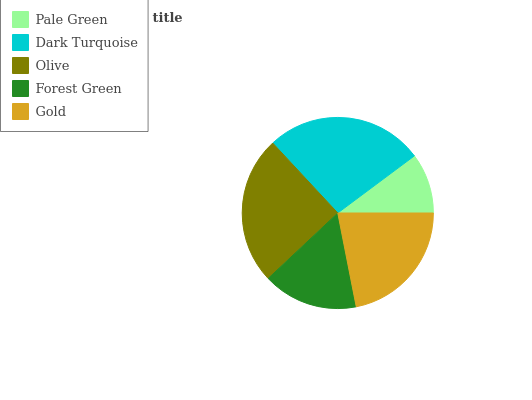Is Pale Green the minimum?
Answer yes or no. Yes. Is Dark Turquoise the maximum?
Answer yes or no. Yes. Is Olive the minimum?
Answer yes or no. No. Is Olive the maximum?
Answer yes or no. No. Is Dark Turquoise greater than Olive?
Answer yes or no. Yes. Is Olive less than Dark Turquoise?
Answer yes or no. Yes. Is Olive greater than Dark Turquoise?
Answer yes or no. No. Is Dark Turquoise less than Olive?
Answer yes or no. No. Is Gold the high median?
Answer yes or no. Yes. Is Gold the low median?
Answer yes or no. Yes. Is Olive the high median?
Answer yes or no. No. Is Dark Turquoise the low median?
Answer yes or no. No. 